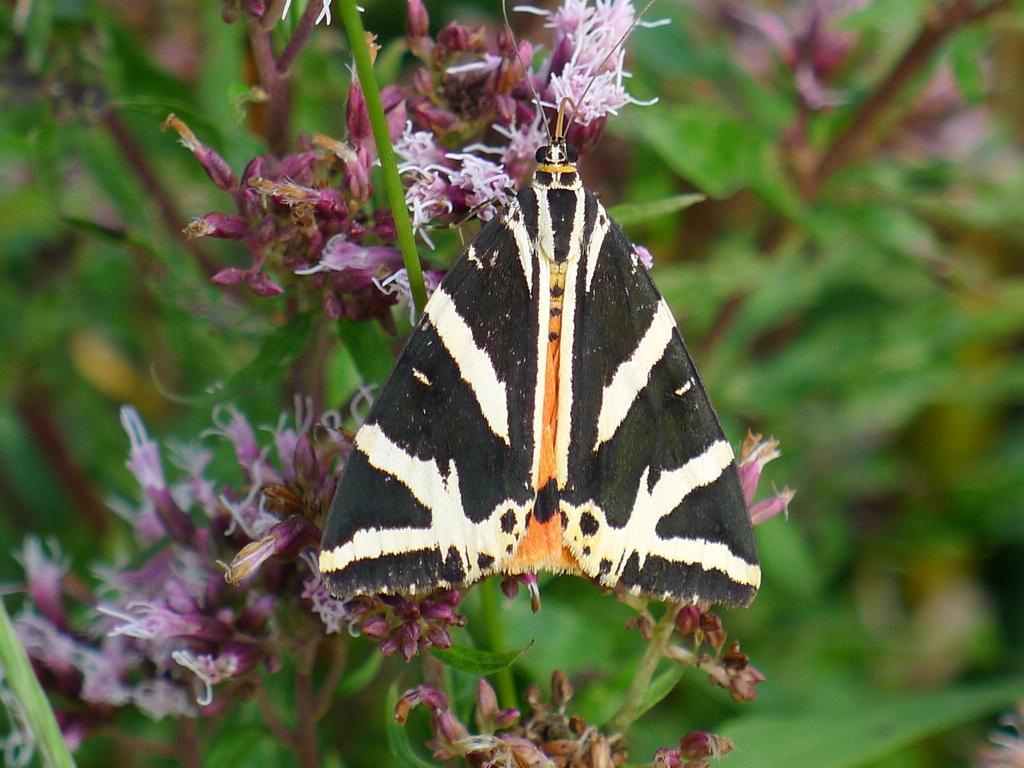How would you summarize this image in a sentence or two? In this image we can see an insect on the flowers and blur background. 